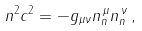Convert formula to latex. <formula><loc_0><loc_0><loc_500><loc_500>n ^ { 2 } c ^ { 2 } = - g _ { \mu \nu } n _ { n } ^ { \, \mu } n _ { n } ^ { \, \nu } \, ,</formula> 